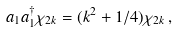<formula> <loc_0><loc_0><loc_500><loc_500>a _ { 1 } a _ { 1 } ^ { \dagger } \chi _ { 2 k } = ( k ^ { 2 } + 1 / 4 ) \chi _ { 2 k } \, ,</formula> 